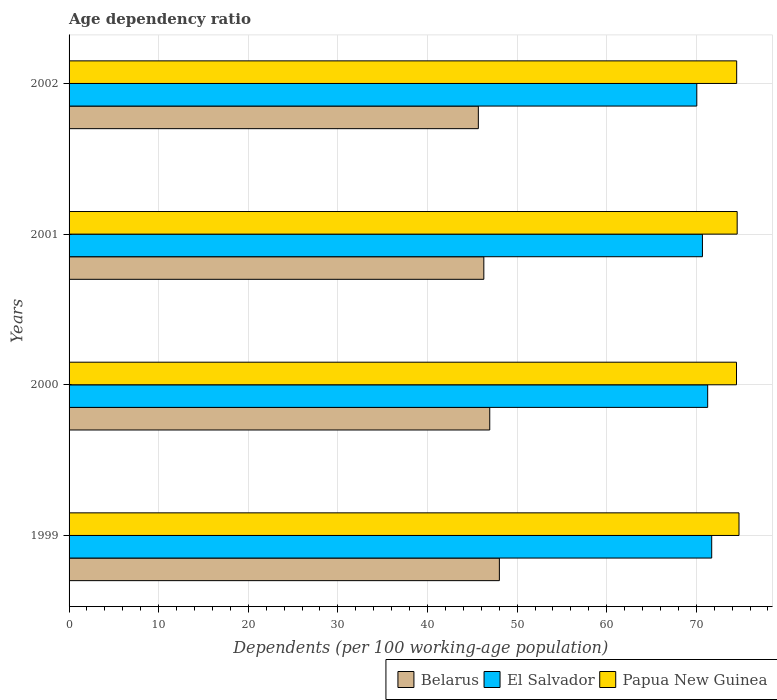How many different coloured bars are there?
Your response must be concise. 3. How many groups of bars are there?
Your answer should be compact. 4. Are the number of bars per tick equal to the number of legend labels?
Give a very brief answer. Yes. Are the number of bars on each tick of the Y-axis equal?
Make the answer very short. Yes. How many bars are there on the 4th tick from the bottom?
Offer a very short reply. 3. What is the age dependency ratio in in El Salvador in 2001?
Your answer should be compact. 70.69. Across all years, what is the maximum age dependency ratio in in Belarus?
Keep it short and to the point. 48.02. Across all years, what is the minimum age dependency ratio in in Belarus?
Keep it short and to the point. 45.68. In which year was the age dependency ratio in in El Salvador maximum?
Offer a very short reply. 1999. What is the total age dependency ratio in in Belarus in the graph?
Provide a short and direct response. 186.93. What is the difference between the age dependency ratio in in Belarus in 2000 and that in 2001?
Offer a very short reply. 0.66. What is the difference between the age dependency ratio in in Papua New Guinea in 1999 and the age dependency ratio in in El Salvador in 2002?
Keep it short and to the point. 4.71. What is the average age dependency ratio in in Papua New Guinea per year?
Your answer should be compact. 74.58. In the year 1999, what is the difference between the age dependency ratio in in Belarus and age dependency ratio in in Papua New Guinea?
Provide a succinct answer. -26.74. What is the ratio of the age dependency ratio in in Papua New Guinea in 2001 to that in 2002?
Your answer should be compact. 1. Is the age dependency ratio in in El Salvador in 1999 less than that in 2002?
Your answer should be compact. No. Is the difference between the age dependency ratio in in Belarus in 2000 and 2001 greater than the difference between the age dependency ratio in in Papua New Guinea in 2000 and 2001?
Offer a terse response. Yes. What is the difference between the highest and the second highest age dependency ratio in in Papua New Guinea?
Provide a succinct answer. 0.2. What is the difference between the highest and the lowest age dependency ratio in in Papua New Guinea?
Provide a short and direct response. 0.28. In how many years, is the age dependency ratio in in El Salvador greater than the average age dependency ratio in in El Salvador taken over all years?
Provide a short and direct response. 2. What does the 1st bar from the top in 1999 represents?
Make the answer very short. Papua New Guinea. What does the 1st bar from the bottom in 2001 represents?
Make the answer very short. Belarus. Is it the case that in every year, the sum of the age dependency ratio in in Papua New Guinea and age dependency ratio in in El Salvador is greater than the age dependency ratio in in Belarus?
Your answer should be compact. Yes. Are all the bars in the graph horizontal?
Your answer should be very brief. Yes. Are the values on the major ticks of X-axis written in scientific E-notation?
Provide a short and direct response. No. Where does the legend appear in the graph?
Provide a short and direct response. Bottom right. How many legend labels are there?
Your answer should be very brief. 3. How are the legend labels stacked?
Make the answer very short. Horizontal. What is the title of the graph?
Offer a very short reply. Age dependency ratio. What is the label or title of the X-axis?
Provide a short and direct response. Dependents (per 100 working-age population). What is the label or title of the Y-axis?
Offer a very short reply. Years. What is the Dependents (per 100 working-age population) in Belarus in 1999?
Your answer should be compact. 48.02. What is the Dependents (per 100 working-age population) of El Salvador in 1999?
Ensure brevity in your answer.  71.72. What is the Dependents (per 100 working-age population) in Papua New Guinea in 1999?
Give a very brief answer. 74.76. What is the Dependents (per 100 working-age population) in Belarus in 2000?
Provide a succinct answer. 46.95. What is the Dependents (per 100 working-age population) in El Salvador in 2000?
Your response must be concise. 71.27. What is the Dependents (per 100 working-age population) in Papua New Guinea in 2000?
Offer a terse response. 74.49. What is the Dependents (per 100 working-age population) in Belarus in 2001?
Ensure brevity in your answer.  46.29. What is the Dependents (per 100 working-age population) of El Salvador in 2001?
Provide a short and direct response. 70.69. What is the Dependents (per 100 working-age population) in Papua New Guinea in 2001?
Give a very brief answer. 74.56. What is the Dependents (per 100 working-age population) of Belarus in 2002?
Offer a very short reply. 45.68. What is the Dependents (per 100 working-age population) in El Salvador in 2002?
Make the answer very short. 70.05. What is the Dependents (per 100 working-age population) of Papua New Guinea in 2002?
Ensure brevity in your answer.  74.51. Across all years, what is the maximum Dependents (per 100 working-age population) in Belarus?
Offer a terse response. 48.02. Across all years, what is the maximum Dependents (per 100 working-age population) of El Salvador?
Make the answer very short. 71.72. Across all years, what is the maximum Dependents (per 100 working-age population) in Papua New Guinea?
Your answer should be very brief. 74.76. Across all years, what is the minimum Dependents (per 100 working-age population) of Belarus?
Provide a succinct answer. 45.68. Across all years, what is the minimum Dependents (per 100 working-age population) in El Salvador?
Give a very brief answer. 70.05. Across all years, what is the minimum Dependents (per 100 working-age population) of Papua New Guinea?
Provide a succinct answer. 74.49. What is the total Dependents (per 100 working-age population) of Belarus in the graph?
Offer a terse response. 186.93. What is the total Dependents (per 100 working-age population) in El Salvador in the graph?
Your answer should be very brief. 283.73. What is the total Dependents (per 100 working-age population) in Papua New Guinea in the graph?
Offer a very short reply. 298.32. What is the difference between the Dependents (per 100 working-age population) of Belarus in 1999 and that in 2000?
Your response must be concise. 1.07. What is the difference between the Dependents (per 100 working-age population) in El Salvador in 1999 and that in 2000?
Offer a terse response. 0.45. What is the difference between the Dependents (per 100 working-age population) in Papua New Guinea in 1999 and that in 2000?
Make the answer very short. 0.28. What is the difference between the Dependents (per 100 working-age population) of Belarus in 1999 and that in 2001?
Ensure brevity in your answer.  1.74. What is the difference between the Dependents (per 100 working-age population) of Papua New Guinea in 1999 and that in 2001?
Give a very brief answer. 0.2. What is the difference between the Dependents (per 100 working-age population) of Belarus in 1999 and that in 2002?
Your response must be concise. 2.35. What is the difference between the Dependents (per 100 working-age population) in El Salvador in 1999 and that in 2002?
Your response must be concise. 1.66. What is the difference between the Dependents (per 100 working-age population) in Papua New Guinea in 1999 and that in 2002?
Offer a terse response. 0.26. What is the difference between the Dependents (per 100 working-age population) of Belarus in 2000 and that in 2001?
Provide a short and direct response. 0.66. What is the difference between the Dependents (per 100 working-age population) in El Salvador in 2000 and that in 2001?
Your answer should be very brief. 0.58. What is the difference between the Dependents (per 100 working-age population) of Papua New Guinea in 2000 and that in 2001?
Your response must be concise. -0.08. What is the difference between the Dependents (per 100 working-age population) of Belarus in 2000 and that in 2002?
Keep it short and to the point. 1.27. What is the difference between the Dependents (per 100 working-age population) in El Salvador in 2000 and that in 2002?
Your answer should be compact. 1.21. What is the difference between the Dependents (per 100 working-age population) of Papua New Guinea in 2000 and that in 2002?
Your response must be concise. -0.02. What is the difference between the Dependents (per 100 working-age population) in Belarus in 2001 and that in 2002?
Offer a very short reply. 0.61. What is the difference between the Dependents (per 100 working-age population) of El Salvador in 2001 and that in 2002?
Provide a short and direct response. 0.63. What is the difference between the Dependents (per 100 working-age population) in Papua New Guinea in 2001 and that in 2002?
Provide a short and direct response. 0.05. What is the difference between the Dependents (per 100 working-age population) in Belarus in 1999 and the Dependents (per 100 working-age population) in El Salvador in 2000?
Your answer should be very brief. -23.25. What is the difference between the Dependents (per 100 working-age population) of Belarus in 1999 and the Dependents (per 100 working-age population) of Papua New Guinea in 2000?
Ensure brevity in your answer.  -26.46. What is the difference between the Dependents (per 100 working-age population) of El Salvador in 1999 and the Dependents (per 100 working-age population) of Papua New Guinea in 2000?
Provide a succinct answer. -2.77. What is the difference between the Dependents (per 100 working-age population) in Belarus in 1999 and the Dependents (per 100 working-age population) in El Salvador in 2001?
Ensure brevity in your answer.  -22.66. What is the difference between the Dependents (per 100 working-age population) of Belarus in 1999 and the Dependents (per 100 working-age population) of Papua New Guinea in 2001?
Ensure brevity in your answer.  -26.54. What is the difference between the Dependents (per 100 working-age population) of El Salvador in 1999 and the Dependents (per 100 working-age population) of Papua New Guinea in 2001?
Offer a terse response. -2.84. What is the difference between the Dependents (per 100 working-age population) in Belarus in 1999 and the Dependents (per 100 working-age population) in El Salvador in 2002?
Give a very brief answer. -22.03. What is the difference between the Dependents (per 100 working-age population) of Belarus in 1999 and the Dependents (per 100 working-age population) of Papua New Guinea in 2002?
Provide a short and direct response. -26.48. What is the difference between the Dependents (per 100 working-age population) in El Salvador in 1999 and the Dependents (per 100 working-age population) in Papua New Guinea in 2002?
Ensure brevity in your answer.  -2.79. What is the difference between the Dependents (per 100 working-age population) of Belarus in 2000 and the Dependents (per 100 working-age population) of El Salvador in 2001?
Make the answer very short. -23.74. What is the difference between the Dependents (per 100 working-age population) of Belarus in 2000 and the Dependents (per 100 working-age population) of Papua New Guinea in 2001?
Your answer should be very brief. -27.61. What is the difference between the Dependents (per 100 working-age population) in El Salvador in 2000 and the Dependents (per 100 working-age population) in Papua New Guinea in 2001?
Your answer should be compact. -3.29. What is the difference between the Dependents (per 100 working-age population) in Belarus in 2000 and the Dependents (per 100 working-age population) in El Salvador in 2002?
Your answer should be very brief. -23.11. What is the difference between the Dependents (per 100 working-age population) of Belarus in 2000 and the Dependents (per 100 working-age population) of Papua New Guinea in 2002?
Provide a short and direct response. -27.56. What is the difference between the Dependents (per 100 working-age population) of El Salvador in 2000 and the Dependents (per 100 working-age population) of Papua New Guinea in 2002?
Make the answer very short. -3.24. What is the difference between the Dependents (per 100 working-age population) in Belarus in 2001 and the Dependents (per 100 working-age population) in El Salvador in 2002?
Ensure brevity in your answer.  -23.77. What is the difference between the Dependents (per 100 working-age population) of Belarus in 2001 and the Dependents (per 100 working-age population) of Papua New Guinea in 2002?
Your answer should be very brief. -28.22. What is the difference between the Dependents (per 100 working-age population) in El Salvador in 2001 and the Dependents (per 100 working-age population) in Papua New Guinea in 2002?
Your answer should be compact. -3.82. What is the average Dependents (per 100 working-age population) in Belarus per year?
Your answer should be compact. 46.73. What is the average Dependents (per 100 working-age population) of El Salvador per year?
Provide a short and direct response. 70.93. What is the average Dependents (per 100 working-age population) of Papua New Guinea per year?
Your response must be concise. 74.58. In the year 1999, what is the difference between the Dependents (per 100 working-age population) of Belarus and Dependents (per 100 working-age population) of El Salvador?
Offer a terse response. -23.7. In the year 1999, what is the difference between the Dependents (per 100 working-age population) in Belarus and Dependents (per 100 working-age population) in Papua New Guinea?
Offer a very short reply. -26.74. In the year 1999, what is the difference between the Dependents (per 100 working-age population) of El Salvador and Dependents (per 100 working-age population) of Papua New Guinea?
Your response must be concise. -3.05. In the year 2000, what is the difference between the Dependents (per 100 working-age population) in Belarus and Dependents (per 100 working-age population) in El Salvador?
Your response must be concise. -24.32. In the year 2000, what is the difference between the Dependents (per 100 working-age population) in Belarus and Dependents (per 100 working-age population) in Papua New Guinea?
Make the answer very short. -27.54. In the year 2000, what is the difference between the Dependents (per 100 working-age population) in El Salvador and Dependents (per 100 working-age population) in Papua New Guinea?
Provide a succinct answer. -3.22. In the year 2001, what is the difference between the Dependents (per 100 working-age population) in Belarus and Dependents (per 100 working-age population) in El Salvador?
Make the answer very short. -24.4. In the year 2001, what is the difference between the Dependents (per 100 working-age population) of Belarus and Dependents (per 100 working-age population) of Papua New Guinea?
Provide a short and direct response. -28.27. In the year 2001, what is the difference between the Dependents (per 100 working-age population) of El Salvador and Dependents (per 100 working-age population) of Papua New Guinea?
Provide a succinct answer. -3.88. In the year 2002, what is the difference between the Dependents (per 100 working-age population) of Belarus and Dependents (per 100 working-age population) of El Salvador?
Ensure brevity in your answer.  -24.38. In the year 2002, what is the difference between the Dependents (per 100 working-age population) in Belarus and Dependents (per 100 working-age population) in Papua New Guinea?
Keep it short and to the point. -28.83. In the year 2002, what is the difference between the Dependents (per 100 working-age population) of El Salvador and Dependents (per 100 working-age population) of Papua New Guinea?
Ensure brevity in your answer.  -4.45. What is the ratio of the Dependents (per 100 working-age population) in Belarus in 1999 to that in 2000?
Provide a short and direct response. 1.02. What is the ratio of the Dependents (per 100 working-age population) in Belarus in 1999 to that in 2001?
Offer a very short reply. 1.04. What is the ratio of the Dependents (per 100 working-age population) of El Salvador in 1999 to that in 2001?
Your response must be concise. 1.01. What is the ratio of the Dependents (per 100 working-age population) in Belarus in 1999 to that in 2002?
Provide a succinct answer. 1.05. What is the ratio of the Dependents (per 100 working-age population) of El Salvador in 1999 to that in 2002?
Your response must be concise. 1.02. What is the ratio of the Dependents (per 100 working-age population) of Papua New Guinea in 1999 to that in 2002?
Make the answer very short. 1. What is the ratio of the Dependents (per 100 working-age population) in Belarus in 2000 to that in 2001?
Your answer should be very brief. 1.01. What is the ratio of the Dependents (per 100 working-age population) of El Salvador in 2000 to that in 2001?
Your answer should be compact. 1.01. What is the ratio of the Dependents (per 100 working-age population) of Papua New Guinea in 2000 to that in 2001?
Give a very brief answer. 1. What is the ratio of the Dependents (per 100 working-age population) of Belarus in 2000 to that in 2002?
Your answer should be very brief. 1.03. What is the ratio of the Dependents (per 100 working-age population) of El Salvador in 2000 to that in 2002?
Provide a succinct answer. 1.02. What is the ratio of the Dependents (per 100 working-age population) in Papua New Guinea in 2000 to that in 2002?
Your answer should be compact. 1. What is the ratio of the Dependents (per 100 working-age population) in Belarus in 2001 to that in 2002?
Ensure brevity in your answer.  1.01. What is the difference between the highest and the second highest Dependents (per 100 working-age population) in Belarus?
Offer a very short reply. 1.07. What is the difference between the highest and the second highest Dependents (per 100 working-age population) of El Salvador?
Keep it short and to the point. 0.45. What is the difference between the highest and the second highest Dependents (per 100 working-age population) in Papua New Guinea?
Offer a terse response. 0.2. What is the difference between the highest and the lowest Dependents (per 100 working-age population) of Belarus?
Ensure brevity in your answer.  2.35. What is the difference between the highest and the lowest Dependents (per 100 working-age population) in El Salvador?
Give a very brief answer. 1.66. What is the difference between the highest and the lowest Dependents (per 100 working-age population) of Papua New Guinea?
Provide a short and direct response. 0.28. 